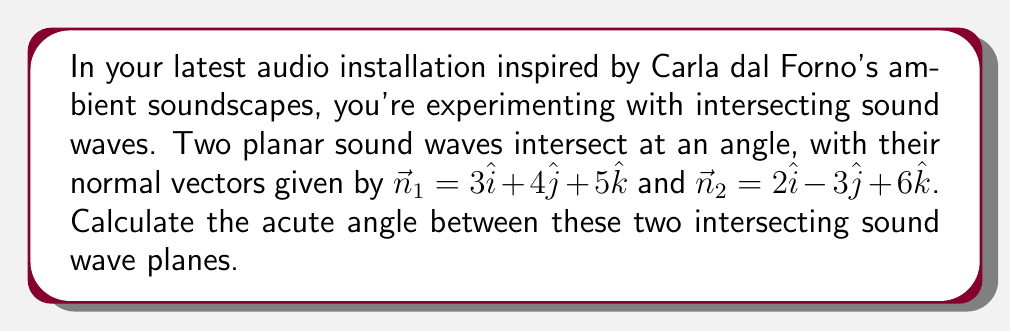Give your solution to this math problem. To find the angle between two intersecting planes, we can use the dot product formula for the angle between two vectors:

1) The formula for the angle $\theta$ between two vectors $\vec{a}$ and $\vec{b}$ is:

   $$\cos \theta = \frac{\vec{a} \cdot \vec{b}}{|\vec{a}||\vec{b}|}$$

2) In our case, $\vec{a} = \vec{n}_1 = 3\hat{i} + 4\hat{j} + 5\hat{k}$ and $\vec{b} = \vec{n}_2 = 2\hat{i} - 3\hat{j} + 6\hat{k}$

3) Calculate the dot product $\vec{n}_1 \cdot \vec{n}_2$:
   $$(3)(2) + (4)(-3) + (5)(6) = 6 - 12 + 30 = 24$$

4) Calculate the magnitudes:
   $$|\vec{n}_1| = \sqrt{3^2 + 4^2 + 5^2} = \sqrt{50}$$
   $$|\vec{n}_2| = \sqrt{2^2 + (-3)^2 + 6^2} = \sqrt{49} = 7$$

5) Substitute into the formula:
   $$\cos \theta = \frac{24}{\sqrt{50} \cdot 7}$$

6) Simplify:
   $$\cos \theta = \frac{24}{7\sqrt{50}} = \frac{24\sqrt{2}}{70}$$

7) Take the inverse cosine (arccos) of both sides:
   $$\theta = \arccos(\frac{24\sqrt{2}}{70})$$

8) Calculate the result (approximately 46.69°)
Answer: $\arccos(\frac{24\sqrt{2}}{70})$ radians or approximately 46.69° 